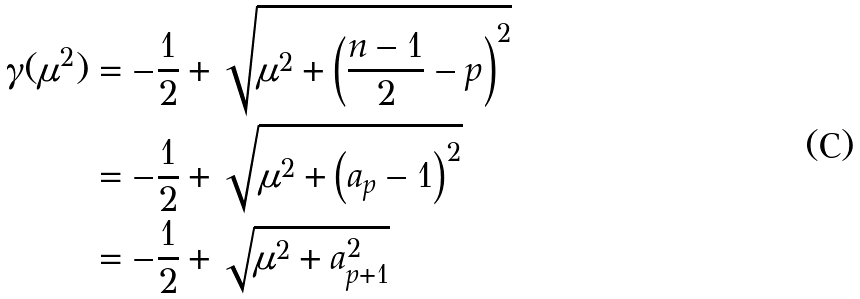<formula> <loc_0><loc_0><loc_500><loc_500>\gamma ( \mu ^ { 2 } ) & = - \frac { 1 } { 2 } + \sqrt { \mu ^ { 2 } + \left ( \frac { n - 1 } { 2 } - p \right ) ^ { 2 } } \\ & = - \frac { 1 } { 2 } + \sqrt { \mu ^ { 2 } + \left ( a _ { p } - 1 \right ) ^ { 2 } } \\ & = - \frac { 1 } { 2 } + \sqrt { \mu ^ { 2 } + a _ { p + 1 } ^ { 2 } }</formula> 